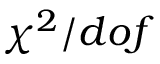Convert formula to latex. <formula><loc_0><loc_0><loc_500><loc_500>\chi ^ { 2 } / d o f</formula> 